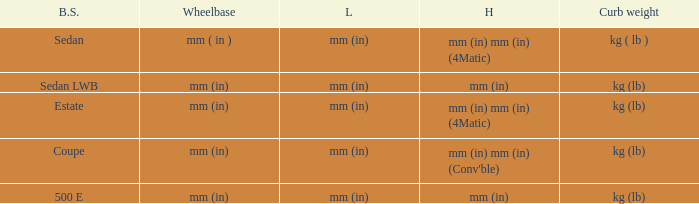What's the length of the model with Sedan body style? Mm (in). 